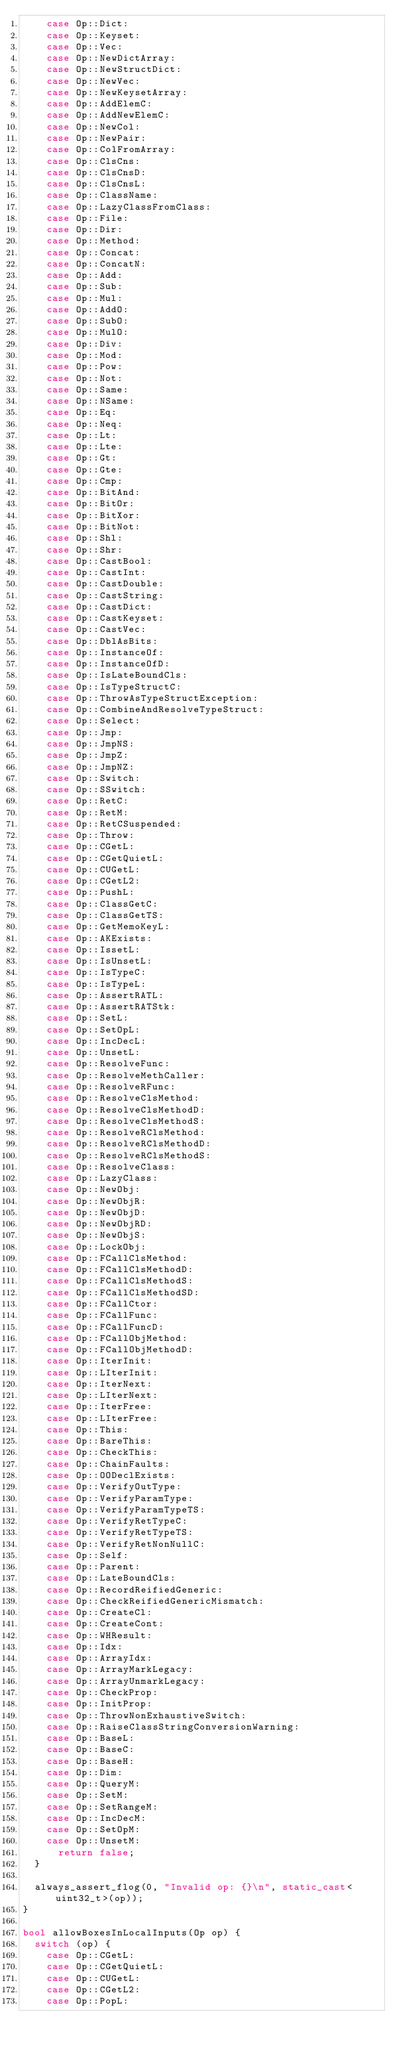<code> <loc_0><loc_0><loc_500><loc_500><_C++_>    case Op::Dict:
    case Op::Keyset:
    case Op::Vec:
    case Op::NewDictArray:
    case Op::NewStructDict:
    case Op::NewVec:
    case Op::NewKeysetArray:
    case Op::AddElemC:
    case Op::AddNewElemC:
    case Op::NewCol:
    case Op::NewPair:
    case Op::ColFromArray:
    case Op::ClsCns:
    case Op::ClsCnsD:
    case Op::ClsCnsL:
    case Op::ClassName:
    case Op::LazyClassFromClass:
    case Op::File:
    case Op::Dir:
    case Op::Method:
    case Op::Concat:
    case Op::ConcatN:
    case Op::Add:
    case Op::Sub:
    case Op::Mul:
    case Op::AddO:
    case Op::SubO:
    case Op::MulO:
    case Op::Div:
    case Op::Mod:
    case Op::Pow:
    case Op::Not:
    case Op::Same:
    case Op::NSame:
    case Op::Eq:
    case Op::Neq:
    case Op::Lt:
    case Op::Lte:
    case Op::Gt:
    case Op::Gte:
    case Op::Cmp:
    case Op::BitAnd:
    case Op::BitOr:
    case Op::BitXor:
    case Op::BitNot:
    case Op::Shl:
    case Op::Shr:
    case Op::CastBool:
    case Op::CastInt:
    case Op::CastDouble:
    case Op::CastString:
    case Op::CastDict:
    case Op::CastKeyset:
    case Op::CastVec:
    case Op::DblAsBits:
    case Op::InstanceOf:
    case Op::InstanceOfD:
    case Op::IsLateBoundCls:
    case Op::IsTypeStructC:
    case Op::ThrowAsTypeStructException:
    case Op::CombineAndResolveTypeStruct:
    case Op::Select:
    case Op::Jmp:
    case Op::JmpNS:
    case Op::JmpZ:
    case Op::JmpNZ:
    case Op::Switch:
    case Op::SSwitch:
    case Op::RetC:
    case Op::RetM:
    case Op::RetCSuspended:
    case Op::Throw:
    case Op::CGetL:
    case Op::CGetQuietL:
    case Op::CUGetL:
    case Op::CGetL2:
    case Op::PushL:
    case Op::ClassGetC:
    case Op::ClassGetTS:
    case Op::GetMemoKeyL:
    case Op::AKExists:
    case Op::IssetL:
    case Op::IsUnsetL:
    case Op::IsTypeC:
    case Op::IsTypeL:
    case Op::AssertRATL:
    case Op::AssertRATStk:
    case Op::SetL:
    case Op::SetOpL:
    case Op::IncDecL:
    case Op::UnsetL:
    case Op::ResolveFunc:
    case Op::ResolveMethCaller:
    case Op::ResolveRFunc:
    case Op::ResolveClsMethod:
    case Op::ResolveClsMethodD:
    case Op::ResolveClsMethodS:
    case Op::ResolveRClsMethod:
    case Op::ResolveRClsMethodD:
    case Op::ResolveRClsMethodS:
    case Op::ResolveClass:
    case Op::LazyClass:
    case Op::NewObj:
    case Op::NewObjR:
    case Op::NewObjD:
    case Op::NewObjRD:
    case Op::NewObjS:
    case Op::LockObj:
    case Op::FCallClsMethod:
    case Op::FCallClsMethodD:
    case Op::FCallClsMethodS:
    case Op::FCallClsMethodSD:
    case Op::FCallCtor:
    case Op::FCallFunc:
    case Op::FCallFuncD:
    case Op::FCallObjMethod:
    case Op::FCallObjMethodD:
    case Op::IterInit:
    case Op::LIterInit:
    case Op::IterNext:
    case Op::LIterNext:
    case Op::IterFree:
    case Op::LIterFree:
    case Op::This:
    case Op::BareThis:
    case Op::CheckThis:
    case Op::ChainFaults:
    case Op::OODeclExists:
    case Op::VerifyOutType:
    case Op::VerifyParamType:
    case Op::VerifyParamTypeTS:
    case Op::VerifyRetTypeC:
    case Op::VerifyRetTypeTS:
    case Op::VerifyRetNonNullC:
    case Op::Self:
    case Op::Parent:
    case Op::LateBoundCls:
    case Op::RecordReifiedGeneric:
    case Op::CheckReifiedGenericMismatch:
    case Op::CreateCl:
    case Op::CreateCont:
    case Op::WHResult:
    case Op::Idx:
    case Op::ArrayIdx:
    case Op::ArrayMarkLegacy:
    case Op::ArrayUnmarkLegacy:
    case Op::CheckProp:
    case Op::InitProp:
    case Op::ThrowNonExhaustiveSwitch:
    case Op::RaiseClassStringConversionWarning:
    case Op::BaseL:
    case Op::BaseC:
    case Op::BaseH:
    case Op::Dim:
    case Op::QueryM:
    case Op::SetM:
    case Op::SetRangeM:
    case Op::IncDecM:
    case Op::SetOpM:
    case Op::UnsetM:
      return false;
  }

  always_assert_flog(0, "Invalid op: {}\n", static_cast<uint32_t>(op));
}

bool allowBoxesInLocalInputs(Op op) {
  switch (op) {
    case Op::CGetL:
    case Op::CGetQuietL:
    case Op::CUGetL:
    case Op::CGetL2:
    case Op::PopL:</code> 